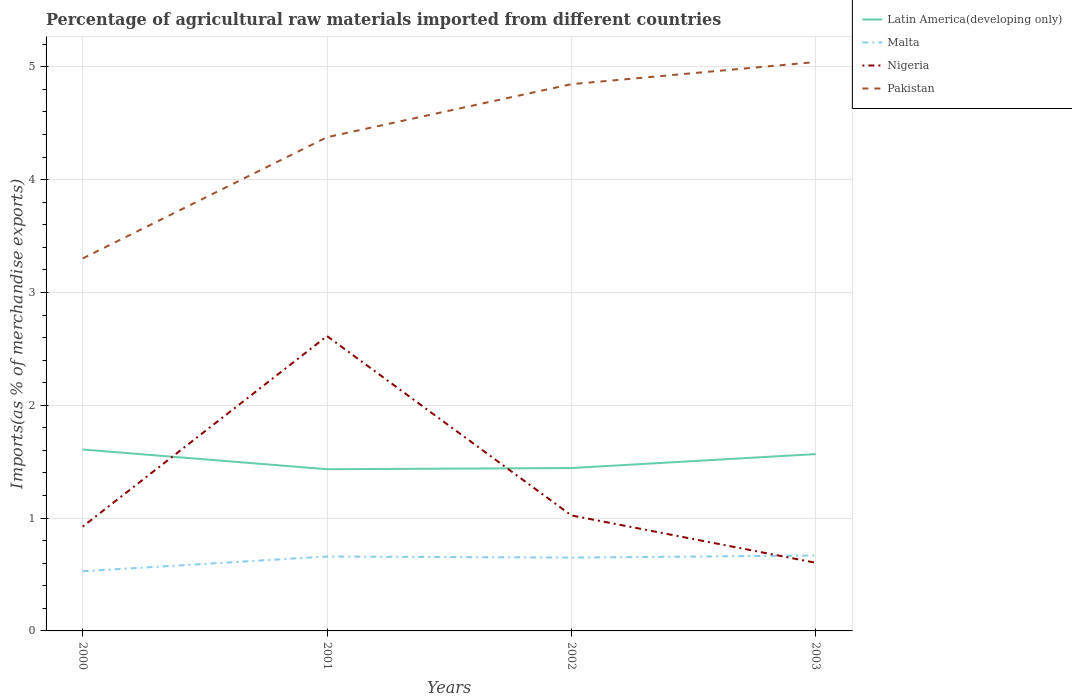Across all years, what is the maximum percentage of imports to different countries in Latin America(developing only)?
Offer a very short reply. 1.43. In which year was the percentage of imports to different countries in Latin America(developing only) maximum?
Your response must be concise. 2001. What is the total percentage of imports to different countries in Pakistan in the graph?
Your response must be concise. -0.47. What is the difference between the highest and the second highest percentage of imports to different countries in Malta?
Your answer should be very brief. 0.14. How many lines are there?
Your answer should be very brief. 4. Are the values on the major ticks of Y-axis written in scientific E-notation?
Provide a short and direct response. No. Does the graph contain any zero values?
Offer a terse response. No. Where does the legend appear in the graph?
Offer a very short reply. Top right. How many legend labels are there?
Offer a very short reply. 4. How are the legend labels stacked?
Your answer should be very brief. Vertical. What is the title of the graph?
Offer a very short reply. Percentage of agricultural raw materials imported from different countries. Does "Bhutan" appear as one of the legend labels in the graph?
Offer a terse response. No. What is the label or title of the Y-axis?
Your answer should be compact. Imports(as % of merchandise exports). What is the Imports(as % of merchandise exports) in Latin America(developing only) in 2000?
Keep it short and to the point. 1.61. What is the Imports(as % of merchandise exports) in Malta in 2000?
Provide a short and direct response. 0.53. What is the Imports(as % of merchandise exports) in Nigeria in 2000?
Keep it short and to the point. 0.92. What is the Imports(as % of merchandise exports) of Pakistan in 2000?
Give a very brief answer. 3.3. What is the Imports(as % of merchandise exports) of Latin America(developing only) in 2001?
Your response must be concise. 1.43. What is the Imports(as % of merchandise exports) in Malta in 2001?
Offer a very short reply. 0.66. What is the Imports(as % of merchandise exports) of Nigeria in 2001?
Give a very brief answer. 2.61. What is the Imports(as % of merchandise exports) of Pakistan in 2001?
Keep it short and to the point. 4.38. What is the Imports(as % of merchandise exports) of Latin America(developing only) in 2002?
Provide a short and direct response. 1.44. What is the Imports(as % of merchandise exports) in Malta in 2002?
Your answer should be very brief. 0.65. What is the Imports(as % of merchandise exports) in Nigeria in 2002?
Provide a short and direct response. 1.02. What is the Imports(as % of merchandise exports) of Pakistan in 2002?
Ensure brevity in your answer.  4.85. What is the Imports(as % of merchandise exports) of Latin America(developing only) in 2003?
Offer a very short reply. 1.57. What is the Imports(as % of merchandise exports) of Malta in 2003?
Provide a succinct answer. 0.67. What is the Imports(as % of merchandise exports) of Nigeria in 2003?
Your answer should be very brief. 0.6. What is the Imports(as % of merchandise exports) in Pakistan in 2003?
Your answer should be compact. 5.04. Across all years, what is the maximum Imports(as % of merchandise exports) in Latin America(developing only)?
Offer a terse response. 1.61. Across all years, what is the maximum Imports(as % of merchandise exports) in Malta?
Your response must be concise. 0.67. Across all years, what is the maximum Imports(as % of merchandise exports) in Nigeria?
Your answer should be compact. 2.61. Across all years, what is the maximum Imports(as % of merchandise exports) of Pakistan?
Give a very brief answer. 5.04. Across all years, what is the minimum Imports(as % of merchandise exports) in Latin America(developing only)?
Give a very brief answer. 1.43. Across all years, what is the minimum Imports(as % of merchandise exports) in Malta?
Keep it short and to the point. 0.53. Across all years, what is the minimum Imports(as % of merchandise exports) in Nigeria?
Your answer should be compact. 0.6. Across all years, what is the minimum Imports(as % of merchandise exports) of Pakistan?
Provide a short and direct response. 3.3. What is the total Imports(as % of merchandise exports) of Latin America(developing only) in the graph?
Offer a very short reply. 6.05. What is the total Imports(as % of merchandise exports) of Malta in the graph?
Your response must be concise. 2.51. What is the total Imports(as % of merchandise exports) of Nigeria in the graph?
Your answer should be very brief. 5.17. What is the total Imports(as % of merchandise exports) in Pakistan in the graph?
Offer a terse response. 17.57. What is the difference between the Imports(as % of merchandise exports) of Latin America(developing only) in 2000 and that in 2001?
Keep it short and to the point. 0.17. What is the difference between the Imports(as % of merchandise exports) of Malta in 2000 and that in 2001?
Make the answer very short. -0.13. What is the difference between the Imports(as % of merchandise exports) in Nigeria in 2000 and that in 2001?
Give a very brief answer. -1.69. What is the difference between the Imports(as % of merchandise exports) in Pakistan in 2000 and that in 2001?
Make the answer very short. -1.07. What is the difference between the Imports(as % of merchandise exports) in Latin America(developing only) in 2000 and that in 2002?
Make the answer very short. 0.16. What is the difference between the Imports(as % of merchandise exports) in Malta in 2000 and that in 2002?
Make the answer very short. -0.12. What is the difference between the Imports(as % of merchandise exports) of Nigeria in 2000 and that in 2002?
Provide a succinct answer. -0.1. What is the difference between the Imports(as % of merchandise exports) of Pakistan in 2000 and that in 2002?
Offer a terse response. -1.54. What is the difference between the Imports(as % of merchandise exports) of Latin America(developing only) in 2000 and that in 2003?
Provide a short and direct response. 0.04. What is the difference between the Imports(as % of merchandise exports) of Malta in 2000 and that in 2003?
Your answer should be compact. -0.14. What is the difference between the Imports(as % of merchandise exports) in Nigeria in 2000 and that in 2003?
Keep it short and to the point. 0.32. What is the difference between the Imports(as % of merchandise exports) in Pakistan in 2000 and that in 2003?
Give a very brief answer. -1.74. What is the difference between the Imports(as % of merchandise exports) of Latin America(developing only) in 2001 and that in 2002?
Give a very brief answer. -0.01. What is the difference between the Imports(as % of merchandise exports) in Malta in 2001 and that in 2002?
Offer a very short reply. 0.01. What is the difference between the Imports(as % of merchandise exports) of Nigeria in 2001 and that in 2002?
Your response must be concise. 1.59. What is the difference between the Imports(as % of merchandise exports) of Pakistan in 2001 and that in 2002?
Your answer should be compact. -0.47. What is the difference between the Imports(as % of merchandise exports) in Latin America(developing only) in 2001 and that in 2003?
Give a very brief answer. -0.13. What is the difference between the Imports(as % of merchandise exports) in Malta in 2001 and that in 2003?
Ensure brevity in your answer.  -0.01. What is the difference between the Imports(as % of merchandise exports) of Nigeria in 2001 and that in 2003?
Keep it short and to the point. 2.01. What is the difference between the Imports(as % of merchandise exports) in Pakistan in 2001 and that in 2003?
Ensure brevity in your answer.  -0.67. What is the difference between the Imports(as % of merchandise exports) of Latin America(developing only) in 2002 and that in 2003?
Your answer should be very brief. -0.12. What is the difference between the Imports(as % of merchandise exports) in Malta in 2002 and that in 2003?
Your response must be concise. -0.02. What is the difference between the Imports(as % of merchandise exports) of Nigeria in 2002 and that in 2003?
Your answer should be compact. 0.42. What is the difference between the Imports(as % of merchandise exports) of Pakistan in 2002 and that in 2003?
Your response must be concise. -0.2. What is the difference between the Imports(as % of merchandise exports) of Latin America(developing only) in 2000 and the Imports(as % of merchandise exports) of Malta in 2001?
Give a very brief answer. 0.95. What is the difference between the Imports(as % of merchandise exports) in Latin America(developing only) in 2000 and the Imports(as % of merchandise exports) in Nigeria in 2001?
Offer a very short reply. -1.01. What is the difference between the Imports(as % of merchandise exports) of Latin America(developing only) in 2000 and the Imports(as % of merchandise exports) of Pakistan in 2001?
Provide a short and direct response. -2.77. What is the difference between the Imports(as % of merchandise exports) in Malta in 2000 and the Imports(as % of merchandise exports) in Nigeria in 2001?
Ensure brevity in your answer.  -2.08. What is the difference between the Imports(as % of merchandise exports) in Malta in 2000 and the Imports(as % of merchandise exports) in Pakistan in 2001?
Ensure brevity in your answer.  -3.85. What is the difference between the Imports(as % of merchandise exports) of Nigeria in 2000 and the Imports(as % of merchandise exports) of Pakistan in 2001?
Keep it short and to the point. -3.45. What is the difference between the Imports(as % of merchandise exports) in Latin America(developing only) in 2000 and the Imports(as % of merchandise exports) in Malta in 2002?
Ensure brevity in your answer.  0.96. What is the difference between the Imports(as % of merchandise exports) of Latin America(developing only) in 2000 and the Imports(as % of merchandise exports) of Nigeria in 2002?
Make the answer very short. 0.58. What is the difference between the Imports(as % of merchandise exports) in Latin America(developing only) in 2000 and the Imports(as % of merchandise exports) in Pakistan in 2002?
Ensure brevity in your answer.  -3.24. What is the difference between the Imports(as % of merchandise exports) of Malta in 2000 and the Imports(as % of merchandise exports) of Nigeria in 2002?
Give a very brief answer. -0.49. What is the difference between the Imports(as % of merchandise exports) of Malta in 2000 and the Imports(as % of merchandise exports) of Pakistan in 2002?
Provide a short and direct response. -4.32. What is the difference between the Imports(as % of merchandise exports) in Nigeria in 2000 and the Imports(as % of merchandise exports) in Pakistan in 2002?
Provide a short and direct response. -3.92. What is the difference between the Imports(as % of merchandise exports) of Latin America(developing only) in 2000 and the Imports(as % of merchandise exports) of Malta in 2003?
Offer a very short reply. 0.94. What is the difference between the Imports(as % of merchandise exports) in Latin America(developing only) in 2000 and the Imports(as % of merchandise exports) in Pakistan in 2003?
Offer a terse response. -3.43. What is the difference between the Imports(as % of merchandise exports) of Malta in 2000 and the Imports(as % of merchandise exports) of Nigeria in 2003?
Ensure brevity in your answer.  -0.08. What is the difference between the Imports(as % of merchandise exports) in Malta in 2000 and the Imports(as % of merchandise exports) in Pakistan in 2003?
Keep it short and to the point. -4.51. What is the difference between the Imports(as % of merchandise exports) in Nigeria in 2000 and the Imports(as % of merchandise exports) in Pakistan in 2003?
Make the answer very short. -4.12. What is the difference between the Imports(as % of merchandise exports) in Latin America(developing only) in 2001 and the Imports(as % of merchandise exports) in Malta in 2002?
Offer a very short reply. 0.78. What is the difference between the Imports(as % of merchandise exports) in Latin America(developing only) in 2001 and the Imports(as % of merchandise exports) in Nigeria in 2002?
Provide a succinct answer. 0.41. What is the difference between the Imports(as % of merchandise exports) in Latin America(developing only) in 2001 and the Imports(as % of merchandise exports) in Pakistan in 2002?
Make the answer very short. -3.41. What is the difference between the Imports(as % of merchandise exports) in Malta in 2001 and the Imports(as % of merchandise exports) in Nigeria in 2002?
Give a very brief answer. -0.36. What is the difference between the Imports(as % of merchandise exports) of Malta in 2001 and the Imports(as % of merchandise exports) of Pakistan in 2002?
Make the answer very short. -4.19. What is the difference between the Imports(as % of merchandise exports) of Nigeria in 2001 and the Imports(as % of merchandise exports) of Pakistan in 2002?
Provide a short and direct response. -2.23. What is the difference between the Imports(as % of merchandise exports) in Latin America(developing only) in 2001 and the Imports(as % of merchandise exports) in Malta in 2003?
Offer a terse response. 0.76. What is the difference between the Imports(as % of merchandise exports) of Latin America(developing only) in 2001 and the Imports(as % of merchandise exports) of Nigeria in 2003?
Make the answer very short. 0.83. What is the difference between the Imports(as % of merchandise exports) of Latin America(developing only) in 2001 and the Imports(as % of merchandise exports) of Pakistan in 2003?
Offer a terse response. -3.61. What is the difference between the Imports(as % of merchandise exports) of Malta in 2001 and the Imports(as % of merchandise exports) of Nigeria in 2003?
Provide a short and direct response. 0.06. What is the difference between the Imports(as % of merchandise exports) of Malta in 2001 and the Imports(as % of merchandise exports) of Pakistan in 2003?
Keep it short and to the point. -4.38. What is the difference between the Imports(as % of merchandise exports) in Nigeria in 2001 and the Imports(as % of merchandise exports) in Pakistan in 2003?
Keep it short and to the point. -2.43. What is the difference between the Imports(as % of merchandise exports) of Latin America(developing only) in 2002 and the Imports(as % of merchandise exports) of Malta in 2003?
Offer a terse response. 0.78. What is the difference between the Imports(as % of merchandise exports) of Latin America(developing only) in 2002 and the Imports(as % of merchandise exports) of Nigeria in 2003?
Offer a terse response. 0.84. What is the difference between the Imports(as % of merchandise exports) of Latin America(developing only) in 2002 and the Imports(as % of merchandise exports) of Pakistan in 2003?
Make the answer very short. -3.6. What is the difference between the Imports(as % of merchandise exports) of Malta in 2002 and the Imports(as % of merchandise exports) of Nigeria in 2003?
Give a very brief answer. 0.05. What is the difference between the Imports(as % of merchandise exports) of Malta in 2002 and the Imports(as % of merchandise exports) of Pakistan in 2003?
Your response must be concise. -4.39. What is the difference between the Imports(as % of merchandise exports) of Nigeria in 2002 and the Imports(as % of merchandise exports) of Pakistan in 2003?
Make the answer very short. -4.02. What is the average Imports(as % of merchandise exports) of Latin America(developing only) per year?
Ensure brevity in your answer.  1.51. What is the average Imports(as % of merchandise exports) of Malta per year?
Your answer should be very brief. 0.63. What is the average Imports(as % of merchandise exports) of Nigeria per year?
Provide a succinct answer. 1.29. What is the average Imports(as % of merchandise exports) of Pakistan per year?
Your answer should be compact. 4.39. In the year 2000, what is the difference between the Imports(as % of merchandise exports) in Latin America(developing only) and Imports(as % of merchandise exports) in Malta?
Your answer should be compact. 1.08. In the year 2000, what is the difference between the Imports(as % of merchandise exports) of Latin America(developing only) and Imports(as % of merchandise exports) of Nigeria?
Give a very brief answer. 0.68. In the year 2000, what is the difference between the Imports(as % of merchandise exports) of Latin America(developing only) and Imports(as % of merchandise exports) of Pakistan?
Ensure brevity in your answer.  -1.69. In the year 2000, what is the difference between the Imports(as % of merchandise exports) of Malta and Imports(as % of merchandise exports) of Nigeria?
Your answer should be very brief. -0.4. In the year 2000, what is the difference between the Imports(as % of merchandise exports) in Malta and Imports(as % of merchandise exports) in Pakistan?
Provide a short and direct response. -2.77. In the year 2000, what is the difference between the Imports(as % of merchandise exports) of Nigeria and Imports(as % of merchandise exports) of Pakistan?
Provide a succinct answer. -2.38. In the year 2001, what is the difference between the Imports(as % of merchandise exports) in Latin America(developing only) and Imports(as % of merchandise exports) in Malta?
Make the answer very short. 0.77. In the year 2001, what is the difference between the Imports(as % of merchandise exports) of Latin America(developing only) and Imports(as % of merchandise exports) of Nigeria?
Give a very brief answer. -1.18. In the year 2001, what is the difference between the Imports(as % of merchandise exports) of Latin America(developing only) and Imports(as % of merchandise exports) of Pakistan?
Offer a very short reply. -2.94. In the year 2001, what is the difference between the Imports(as % of merchandise exports) in Malta and Imports(as % of merchandise exports) in Nigeria?
Keep it short and to the point. -1.95. In the year 2001, what is the difference between the Imports(as % of merchandise exports) in Malta and Imports(as % of merchandise exports) in Pakistan?
Ensure brevity in your answer.  -3.72. In the year 2001, what is the difference between the Imports(as % of merchandise exports) in Nigeria and Imports(as % of merchandise exports) in Pakistan?
Your answer should be compact. -1.76. In the year 2002, what is the difference between the Imports(as % of merchandise exports) of Latin America(developing only) and Imports(as % of merchandise exports) of Malta?
Provide a succinct answer. 0.79. In the year 2002, what is the difference between the Imports(as % of merchandise exports) in Latin America(developing only) and Imports(as % of merchandise exports) in Nigeria?
Provide a succinct answer. 0.42. In the year 2002, what is the difference between the Imports(as % of merchandise exports) in Latin America(developing only) and Imports(as % of merchandise exports) in Pakistan?
Your response must be concise. -3.4. In the year 2002, what is the difference between the Imports(as % of merchandise exports) of Malta and Imports(as % of merchandise exports) of Nigeria?
Your answer should be compact. -0.37. In the year 2002, what is the difference between the Imports(as % of merchandise exports) in Malta and Imports(as % of merchandise exports) in Pakistan?
Provide a succinct answer. -4.2. In the year 2002, what is the difference between the Imports(as % of merchandise exports) of Nigeria and Imports(as % of merchandise exports) of Pakistan?
Keep it short and to the point. -3.82. In the year 2003, what is the difference between the Imports(as % of merchandise exports) in Latin America(developing only) and Imports(as % of merchandise exports) in Malta?
Your answer should be compact. 0.9. In the year 2003, what is the difference between the Imports(as % of merchandise exports) of Latin America(developing only) and Imports(as % of merchandise exports) of Nigeria?
Offer a very short reply. 0.96. In the year 2003, what is the difference between the Imports(as % of merchandise exports) of Latin America(developing only) and Imports(as % of merchandise exports) of Pakistan?
Ensure brevity in your answer.  -3.47. In the year 2003, what is the difference between the Imports(as % of merchandise exports) of Malta and Imports(as % of merchandise exports) of Nigeria?
Your response must be concise. 0.06. In the year 2003, what is the difference between the Imports(as % of merchandise exports) in Malta and Imports(as % of merchandise exports) in Pakistan?
Give a very brief answer. -4.37. In the year 2003, what is the difference between the Imports(as % of merchandise exports) in Nigeria and Imports(as % of merchandise exports) in Pakistan?
Offer a terse response. -4.44. What is the ratio of the Imports(as % of merchandise exports) of Latin America(developing only) in 2000 to that in 2001?
Your answer should be compact. 1.12. What is the ratio of the Imports(as % of merchandise exports) in Malta in 2000 to that in 2001?
Offer a very short reply. 0.8. What is the ratio of the Imports(as % of merchandise exports) of Nigeria in 2000 to that in 2001?
Your answer should be very brief. 0.35. What is the ratio of the Imports(as % of merchandise exports) in Pakistan in 2000 to that in 2001?
Offer a very short reply. 0.75. What is the ratio of the Imports(as % of merchandise exports) in Latin America(developing only) in 2000 to that in 2002?
Offer a very short reply. 1.11. What is the ratio of the Imports(as % of merchandise exports) in Malta in 2000 to that in 2002?
Provide a succinct answer. 0.81. What is the ratio of the Imports(as % of merchandise exports) in Nigeria in 2000 to that in 2002?
Keep it short and to the point. 0.9. What is the ratio of the Imports(as % of merchandise exports) of Pakistan in 2000 to that in 2002?
Your response must be concise. 0.68. What is the ratio of the Imports(as % of merchandise exports) in Malta in 2000 to that in 2003?
Your response must be concise. 0.79. What is the ratio of the Imports(as % of merchandise exports) of Nigeria in 2000 to that in 2003?
Provide a succinct answer. 1.53. What is the ratio of the Imports(as % of merchandise exports) in Pakistan in 2000 to that in 2003?
Offer a very short reply. 0.65. What is the ratio of the Imports(as % of merchandise exports) in Latin America(developing only) in 2001 to that in 2002?
Offer a terse response. 0.99. What is the ratio of the Imports(as % of merchandise exports) of Malta in 2001 to that in 2002?
Give a very brief answer. 1.02. What is the ratio of the Imports(as % of merchandise exports) in Nigeria in 2001 to that in 2002?
Offer a very short reply. 2.55. What is the ratio of the Imports(as % of merchandise exports) in Pakistan in 2001 to that in 2002?
Provide a short and direct response. 0.9. What is the ratio of the Imports(as % of merchandise exports) of Latin America(developing only) in 2001 to that in 2003?
Your answer should be very brief. 0.91. What is the ratio of the Imports(as % of merchandise exports) of Malta in 2001 to that in 2003?
Your answer should be very brief. 0.99. What is the ratio of the Imports(as % of merchandise exports) in Nigeria in 2001 to that in 2003?
Your answer should be compact. 4.33. What is the ratio of the Imports(as % of merchandise exports) in Pakistan in 2001 to that in 2003?
Your answer should be very brief. 0.87. What is the ratio of the Imports(as % of merchandise exports) of Latin America(developing only) in 2002 to that in 2003?
Keep it short and to the point. 0.92. What is the ratio of the Imports(as % of merchandise exports) of Malta in 2002 to that in 2003?
Your answer should be very brief. 0.97. What is the ratio of the Imports(as % of merchandise exports) in Nigeria in 2002 to that in 2003?
Make the answer very short. 1.69. What is the ratio of the Imports(as % of merchandise exports) of Pakistan in 2002 to that in 2003?
Give a very brief answer. 0.96. What is the difference between the highest and the second highest Imports(as % of merchandise exports) in Latin America(developing only)?
Keep it short and to the point. 0.04. What is the difference between the highest and the second highest Imports(as % of merchandise exports) in Malta?
Your response must be concise. 0.01. What is the difference between the highest and the second highest Imports(as % of merchandise exports) in Nigeria?
Give a very brief answer. 1.59. What is the difference between the highest and the second highest Imports(as % of merchandise exports) of Pakistan?
Ensure brevity in your answer.  0.2. What is the difference between the highest and the lowest Imports(as % of merchandise exports) of Latin America(developing only)?
Keep it short and to the point. 0.17. What is the difference between the highest and the lowest Imports(as % of merchandise exports) in Malta?
Provide a short and direct response. 0.14. What is the difference between the highest and the lowest Imports(as % of merchandise exports) of Nigeria?
Keep it short and to the point. 2.01. What is the difference between the highest and the lowest Imports(as % of merchandise exports) in Pakistan?
Provide a succinct answer. 1.74. 